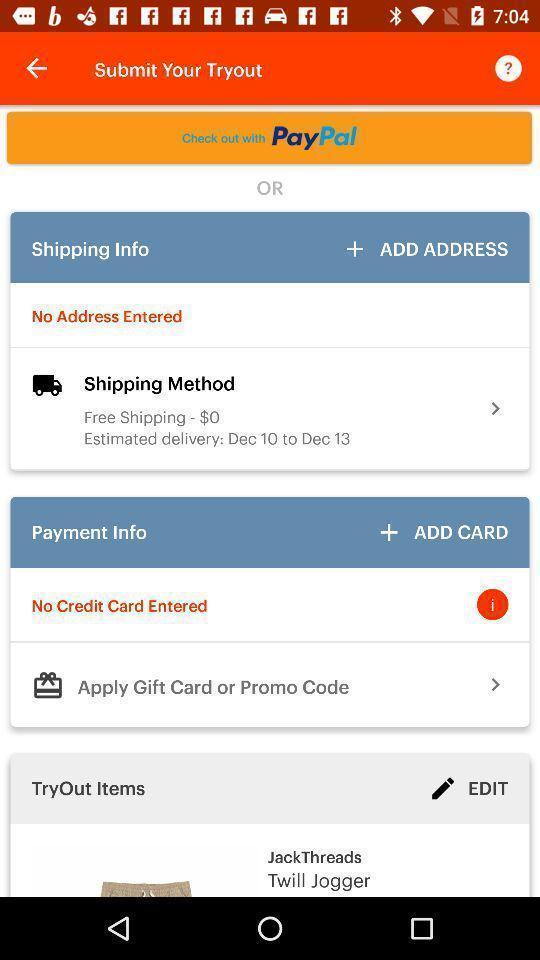Give me a narrative description of this picture. Payment page of a shopping app. 